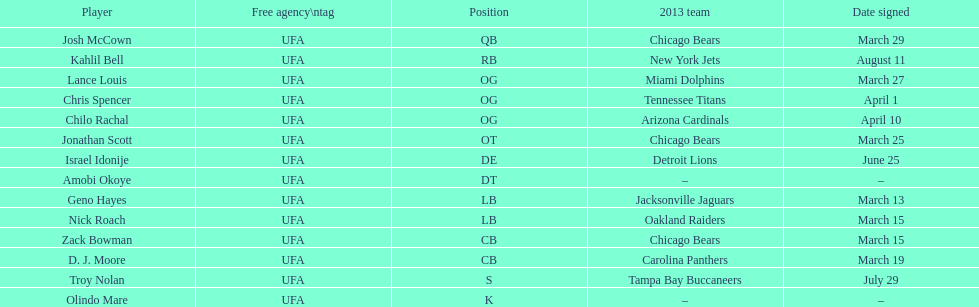What is the sum of all 2013 teams listed on the chart? 10. 